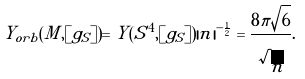Convert formula to latex. <formula><loc_0><loc_0><loc_500><loc_500>Y _ { o r b } ( M , [ g _ { S } ] ) = Y ( S ^ { 4 } , [ g _ { S } ] ) | n | ^ { - \frac { 1 } { 2 } } = \frac { 8 \pi \sqrt { 6 } } { \sqrt { n } } .</formula> 